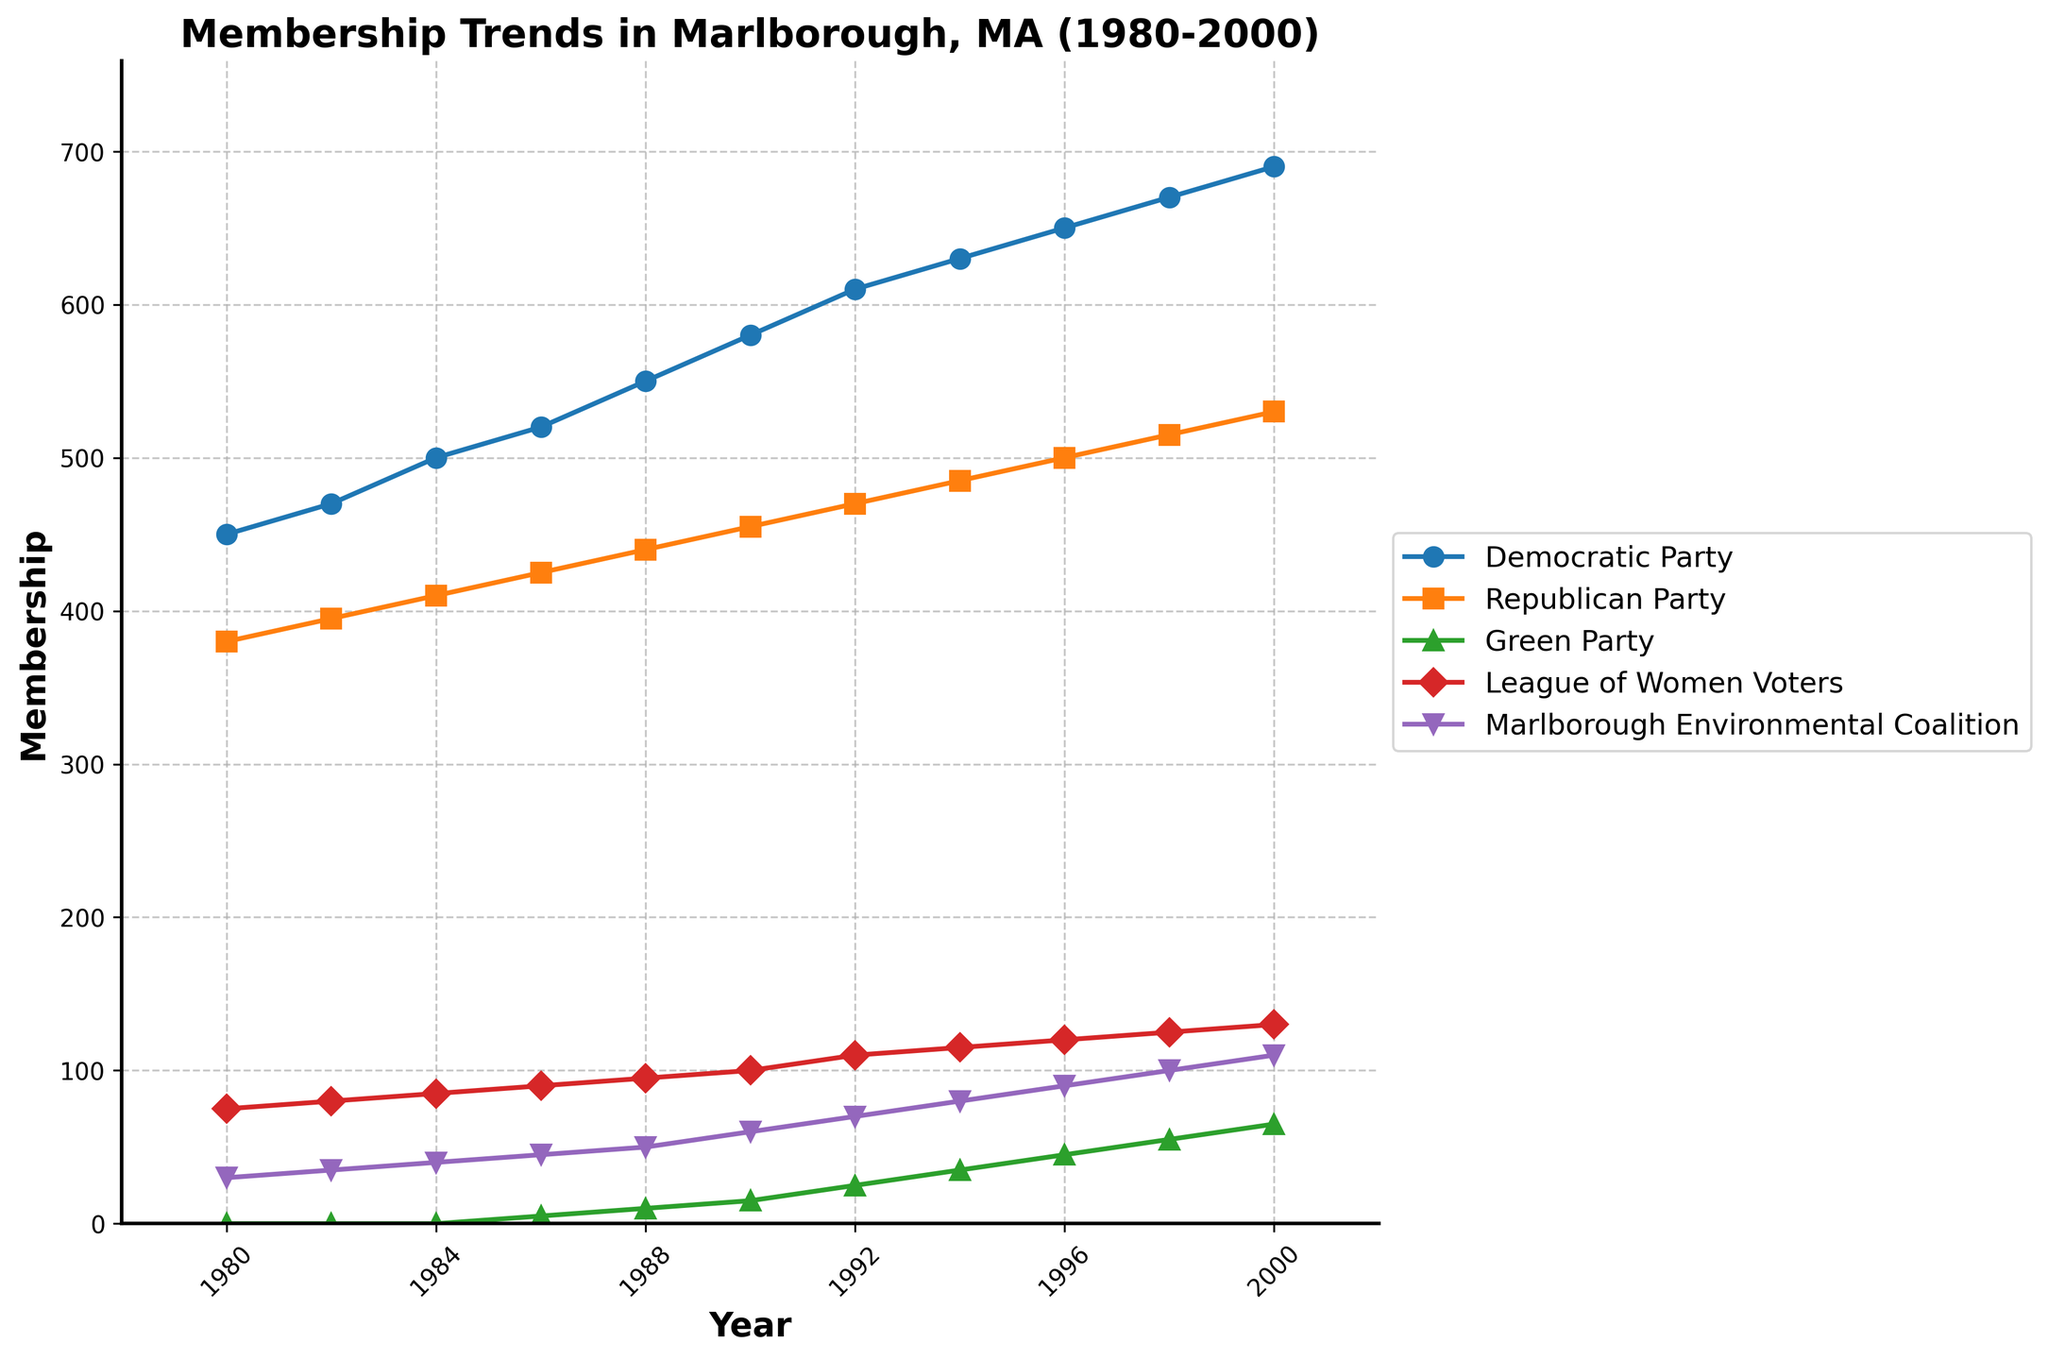Which party had the highest membership in 2000? The Democratic Party had the highest membership in 2000 with 690 members, as it is the last point on the topmost line of the chart.
Answer: Democratic Party How did the membership of the Green Party evolve from 1986 to 2000? In 1986, the Green Party had 5 members, and by 2000 it grew to 65 members. This is seen by tracing the Green Party's line from its initial appearance in 1986 to the year 2000.
Answer: It increased from 5 to 65 members Which group showed a steady upward trend in membership throughout the entire period? The Democratic Party's membership steadily increased from 450 in 1980 to 690 in 2000, which is observed by following the consistent upward slope of its line.
Answer: Democratic Party What is the combined membership of the Republican Party and the League of Women Voters in 1994? In 1994, the Republican Party had 485 members, and the League of Women Voters had 115. Adding these gives a total of 485 + 115 = 600 members.
Answer: 600 Between which years did the Marlborough Environmental Coalition's membership grow the fastest? From 1996 to 2000, the membership rose from 90 to 110, an increase of 20 members. This period shows the steepest slope in the Coalition's line.
Answer: 1996-2000 Did the Republican Party's membership rise or fall between 1990 and 2000? The Republican Party's membership rose from 455 in 1990 to 530 in 2000, as seen from the upward trend in their line.
Answer: Rose Which group had the smallest rate of change in membership between 1990 and 2000? The League of Women Voters increased from 100 members in 1990 to 130 members in 2000, the smallest rate of change compared to other groups.
Answer: League of Women Voters What was the average membership of the Green Party from 1986 to 2000? Adding the values 5, 10, 15, 25, 35, 45, 55, 65 and then dividing by the 9 years: (5+10+15+25+35+45+55+65) / 9 = 28.9
Answer: 28.9 What is the difference in membership between the Democratic Party and the Green Party in 2000? In 2000, the Democratic Party had 690 members, and the Green Party had 65. The difference is 690 - 65 = 625 members.
Answer: 625 